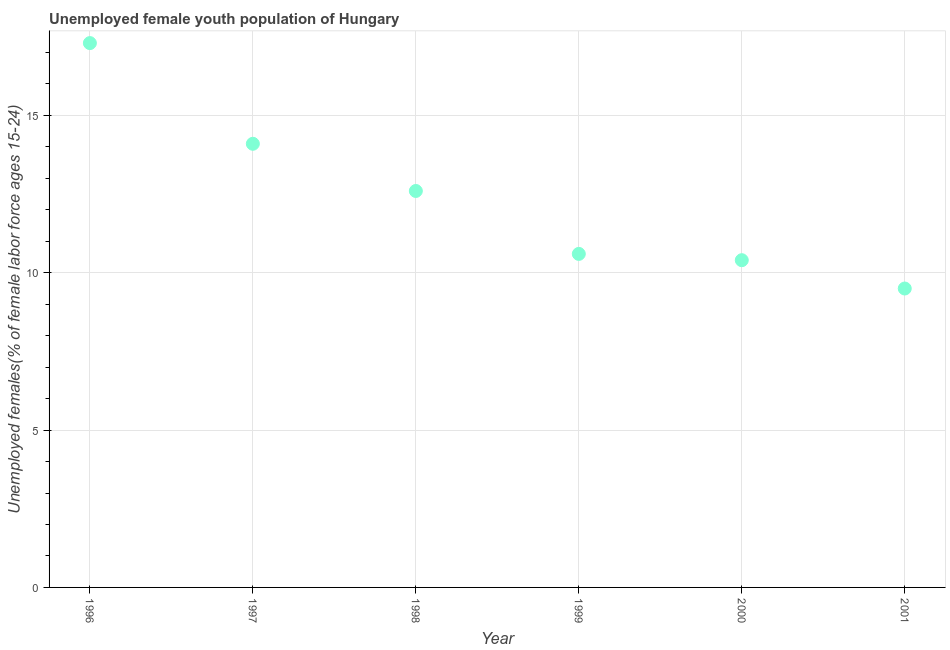What is the unemployed female youth in 1996?
Ensure brevity in your answer.  17.3. Across all years, what is the maximum unemployed female youth?
Keep it short and to the point. 17.3. In which year was the unemployed female youth minimum?
Your response must be concise. 2001. What is the sum of the unemployed female youth?
Your response must be concise. 74.5. What is the difference between the unemployed female youth in 1996 and 2001?
Ensure brevity in your answer.  7.8. What is the average unemployed female youth per year?
Provide a short and direct response. 12.42. What is the median unemployed female youth?
Give a very brief answer. 11.6. Do a majority of the years between 1996 and 1998 (inclusive) have unemployed female youth greater than 4 %?
Offer a terse response. Yes. What is the ratio of the unemployed female youth in 1997 to that in 2001?
Give a very brief answer. 1.48. Is the unemployed female youth in 1997 less than that in 1998?
Make the answer very short. No. What is the difference between the highest and the second highest unemployed female youth?
Make the answer very short. 3.2. Is the sum of the unemployed female youth in 1999 and 2000 greater than the maximum unemployed female youth across all years?
Your answer should be very brief. Yes. What is the difference between the highest and the lowest unemployed female youth?
Offer a terse response. 7.8. Does the unemployed female youth monotonically increase over the years?
Offer a terse response. No. How many dotlines are there?
Make the answer very short. 1. How many years are there in the graph?
Keep it short and to the point. 6. What is the difference between two consecutive major ticks on the Y-axis?
Offer a very short reply. 5. Are the values on the major ticks of Y-axis written in scientific E-notation?
Make the answer very short. No. Does the graph contain any zero values?
Offer a terse response. No. Does the graph contain grids?
Your answer should be very brief. Yes. What is the title of the graph?
Offer a terse response. Unemployed female youth population of Hungary. What is the label or title of the Y-axis?
Give a very brief answer. Unemployed females(% of female labor force ages 15-24). What is the Unemployed females(% of female labor force ages 15-24) in 1996?
Make the answer very short. 17.3. What is the Unemployed females(% of female labor force ages 15-24) in 1997?
Keep it short and to the point. 14.1. What is the Unemployed females(% of female labor force ages 15-24) in 1998?
Your answer should be very brief. 12.6. What is the Unemployed females(% of female labor force ages 15-24) in 1999?
Your answer should be very brief. 10.6. What is the Unemployed females(% of female labor force ages 15-24) in 2000?
Offer a terse response. 10.4. What is the Unemployed females(% of female labor force ages 15-24) in 2001?
Provide a succinct answer. 9.5. What is the difference between the Unemployed females(% of female labor force ages 15-24) in 1996 and 1997?
Your answer should be compact. 3.2. What is the difference between the Unemployed females(% of female labor force ages 15-24) in 1996 and 1998?
Ensure brevity in your answer.  4.7. What is the difference between the Unemployed females(% of female labor force ages 15-24) in 1996 and 1999?
Provide a short and direct response. 6.7. What is the difference between the Unemployed females(% of female labor force ages 15-24) in 1996 and 2000?
Ensure brevity in your answer.  6.9. What is the difference between the Unemployed females(% of female labor force ages 15-24) in 1997 and 1999?
Ensure brevity in your answer.  3.5. What is the difference between the Unemployed females(% of female labor force ages 15-24) in 1997 and 2000?
Your answer should be very brief. 3.7. What is the difference between the Unemployed females(% of female labor force ages 15-24) in 1999 and 2000?
Provide a succinct answer. 0.2. What is the difference between the Unemployed females(% of female labor force ages 15-24) in 2000 and 2001?
Give a very brief answer. 0.9. What is the ratio of the Unemployed females(% of female labor force ages 15-24) in 1996 to that in 1997?
Provide a succinct answer. 1.23. What is the ratio of the Unemployed females(% of female labor force ages 15-24) in 1996 to that in 1998?
Your answer should be compact. 1.37. What is the ratio of the Unemployed females(% of female labor force ages 15-24) in 1996 to that in 1999?
Provide a short and direct response. 1.63. What is the ratio of the Unemployed females(% of female labor force ages 15-24) in 1996 to that in 2000?
Your response must be concise. 1.66. What is the ratio of the Unemployed females(% of female labor force ages 15-24) in 1996 to that in 2001?
Give a very brief answer. 1.82. What is the ratio of the Unemployed females(% of female labor force ages 15-24) in 1997 to that in 1998?
Give a very brief answer. 1.12. What is the ratio of the Unemployed females(% of female labor force ages 15-24) in 1997 to that in 1999?
Give a very brief answer. 1.33. What is the ratio of the Unemployed females(% of female labor force ages 15-24) in 1997 to that in 2000?
Offer a terse response. 1.36. What is the ratio of the Unemployed females(% of female labor force ages 15-24) in 1997 to that in 2001?
Keep it short and to the point. 1.48. What is the ratio of the Unemployed females(% of female labor force ages 15-24) in 1998 to that in 1999?
Your response must be concise. 1.19. What is the ratio of the Unemployed females(% of female labor force ages 15-24) in 1998 to that in 2000?
Offer a terse response. 1.21. What is the ratio of the Unemployed females(% of female labor force ages 15-24) in 1998 to that in 2001?
Your answer should be very brief. 1.33. What is the ratio of the Unemployed females(% of female labor force ages 15-24) in 1999 to that in 2001?
Provide a short and direct response. 1.12. What is the ratio of the Unemployed females(% of female labor force ages 15-24) in 2000 to that in 2001?
Provide a short and direct response. 1.09. 